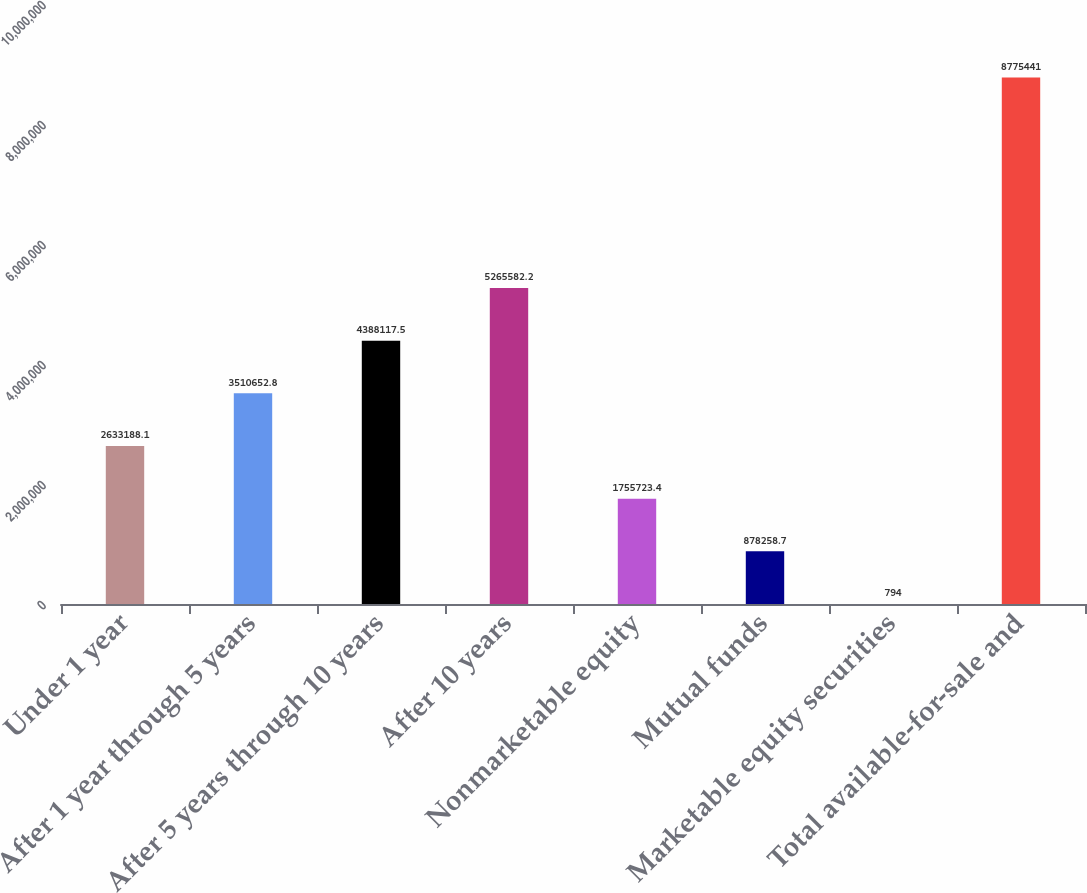<chart> <loc_0><loc_0><loc_500><loc_500><bar_chart><fcel>Under 1 year<fcel>After 1 year through 5 years<fcel>After 5 years through 10 years<fcel>After 10 years<fcel>Nonmarketable equity<fcel>Mutual funds<fcel>Marketable equity securities<fcel>Total available-for-sale and<nl><fcel>2.63319e+06<fcel>3.51065e+06<fcel>4.38812e+06<fcel>5.26558e+06<fcel>1.75572e+06<fcel>878259<fcel>794<fcel>8.77544e+06<nl></chart> 